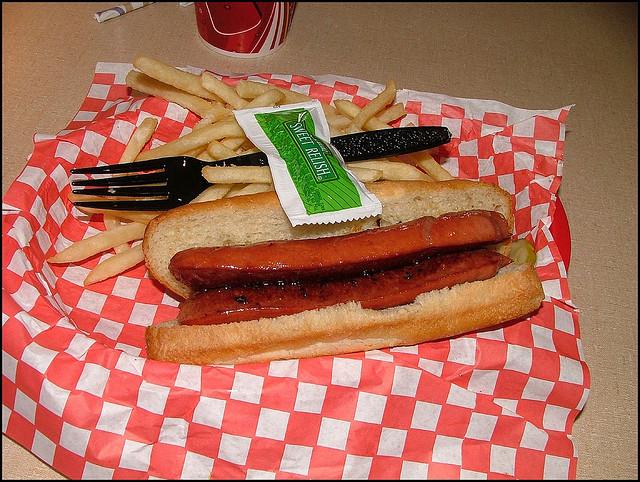What is in the green packet?
Answer briefly. Relish. Does the hot dog fit the bun?
Quick response, please. Yes. Will the contents of the green bag make the hot dog taste better?
Write a very short answer. Yes. What color is the fork?
Keep it brief. Black. 